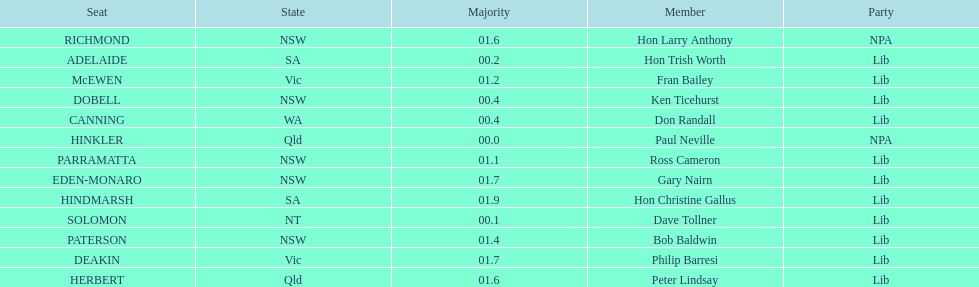How many members in total? 13. 